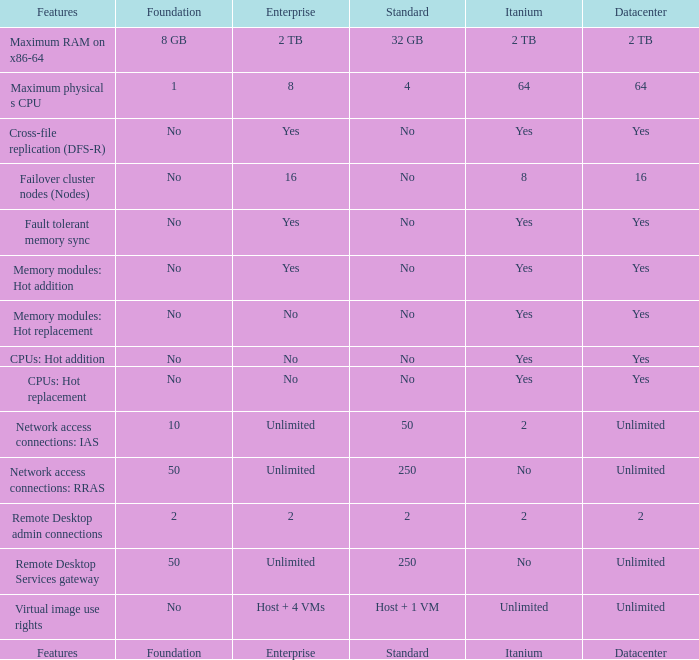What is the Enterprise for teh memory modules: hot replacement Feature that has a Datacenter of Yes? No. 